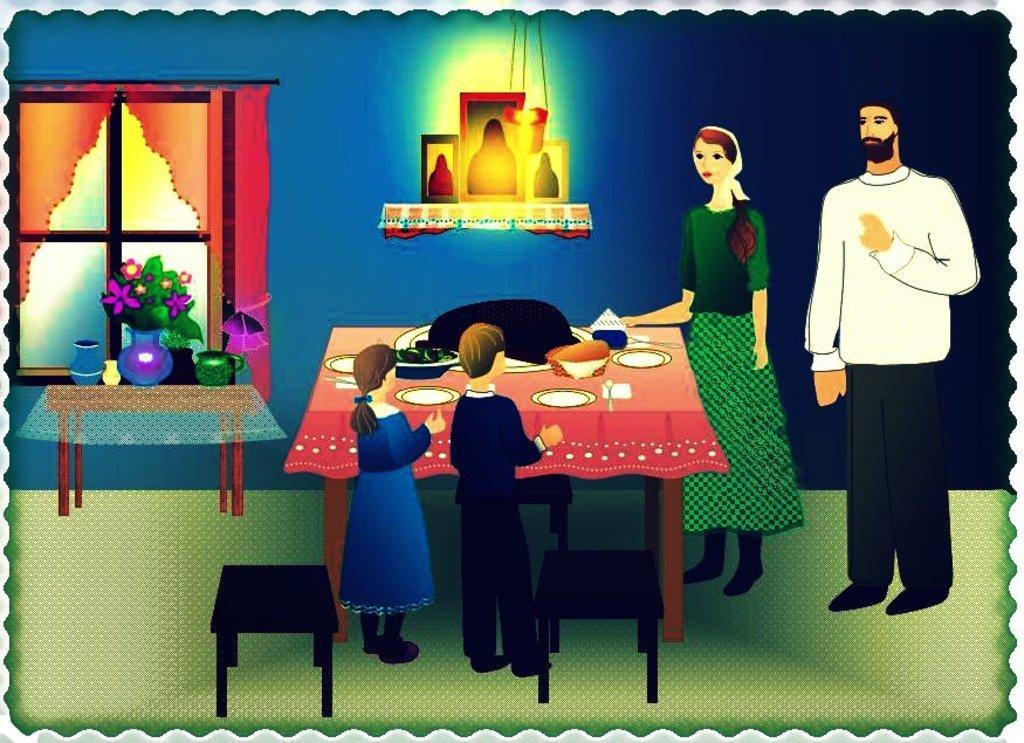Describe this image in one or two sentences. In this image there is an animation picture in which there is a boy and a girl on the right side. In front of them there is a table on which there are plates,glasses and some food. Beside the table there are two kids. On the left side there is a table on which there are flower pots. In the background there is a window with the curtain. At the top there is the light. To the wall there are photo frames. 